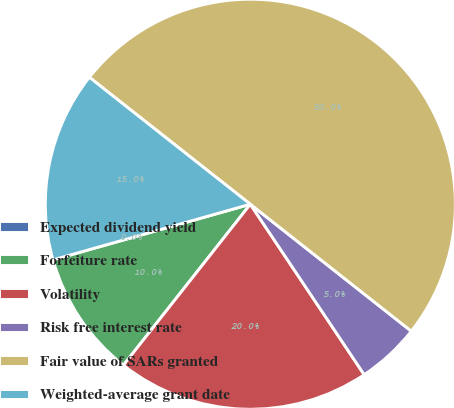<chart> <loc_0><loc_0><loc_500><loc_500><pie_chart><fcel>Expected dividend yield<fcel>Forfeiture rate<fcel>Volatility<fcel>Risk free interest rate<fcel>Fair value of SARs granted<fcel>Weighted-average grant date<nl><fcel>0.0%<fcel>10.0%<fcel>20.0%<fcel>5.0%<fcel>50.0%<fcel>15.0%<nl></chart> 